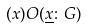<formula> <loc_0><loc_0><loc_500><loc_500>( x ) O ( \underline { x } \colon G )</formula> 